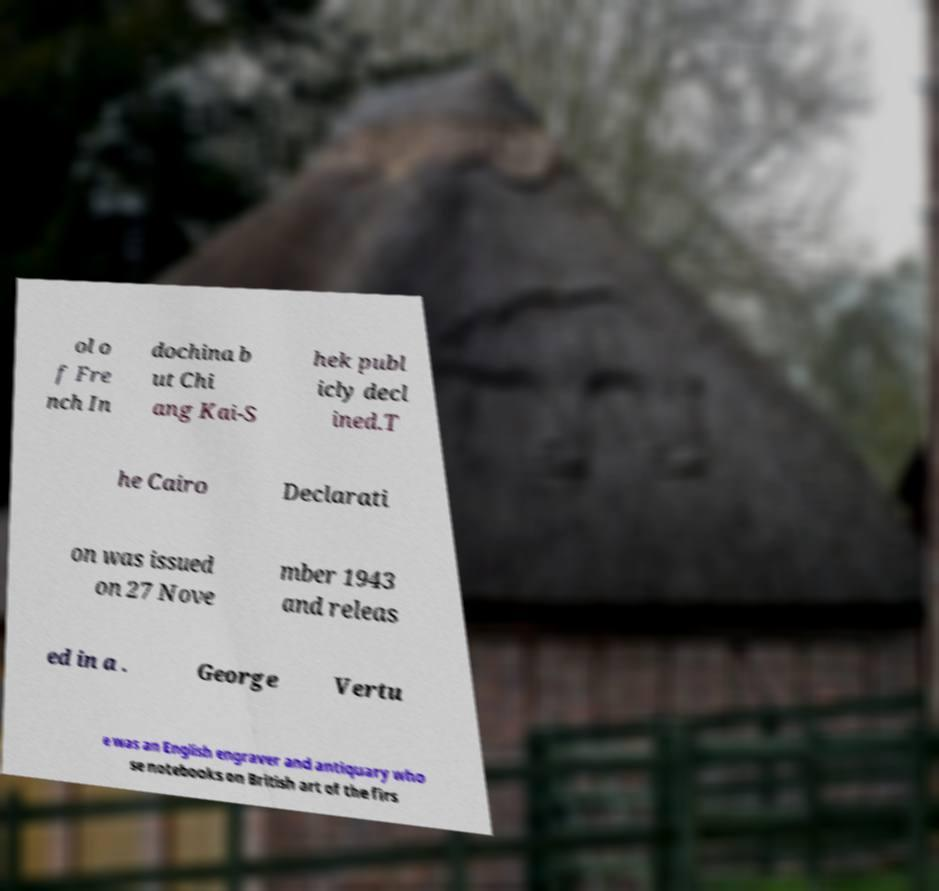Could you extract and type out the text from this image? ol o f Fre nch In dochina b ut Chi ang Kai-S hek publ icly decl ined.T he Cairo Declarati on was issued on 27 Nove mber 1943 and releas ed in a . George Vertu e was an English engraver and antiquary who se notebooks on British art of the firs 